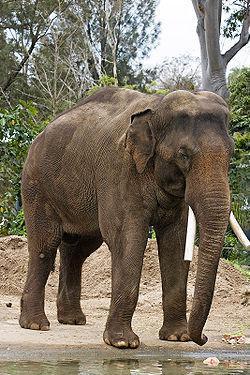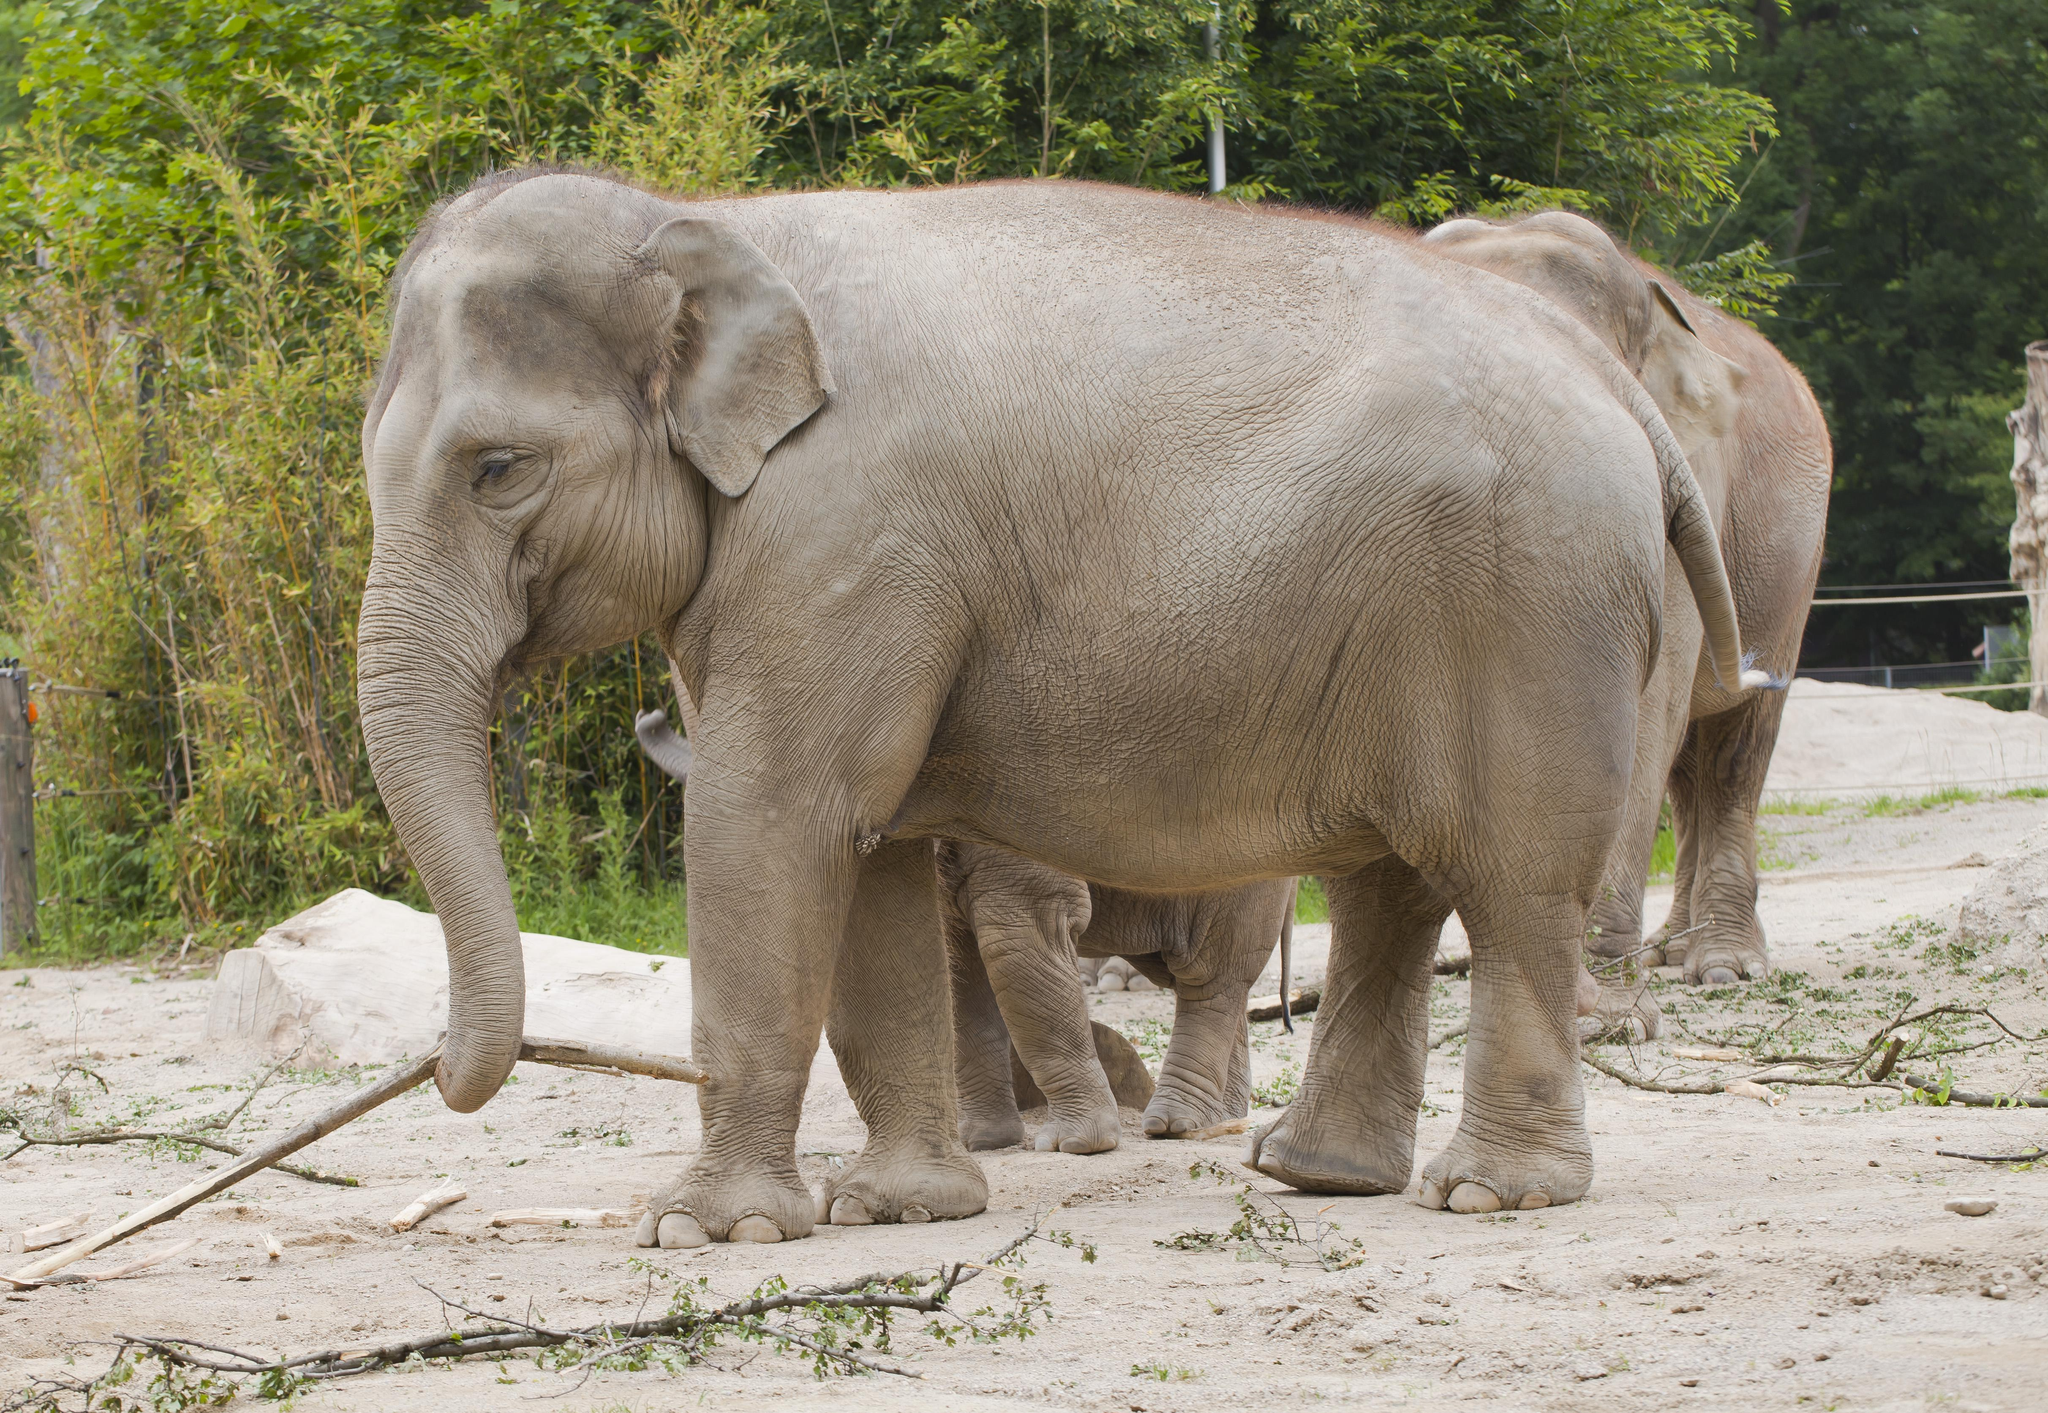The first image is the image on the left, the second image is the image on the right. Evaluate the accuracy of this statement regarding the images: "Multiple pairs of elephant tusks are visible.". Is it true? Answer yes or no. No. 